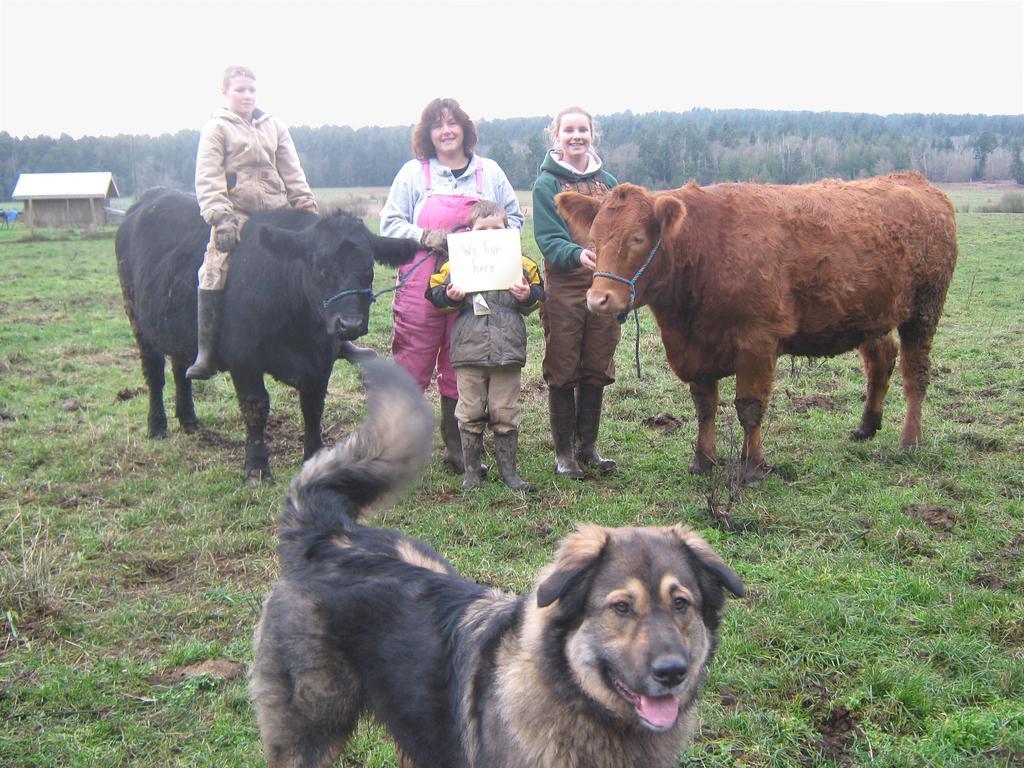Describe this image in one or two sentences. In this image I can see the ground, few animals standing on the ground, a person sitting on the animal and few persons standing on the ground. In the background I can see a shed, few trees and the sky. 